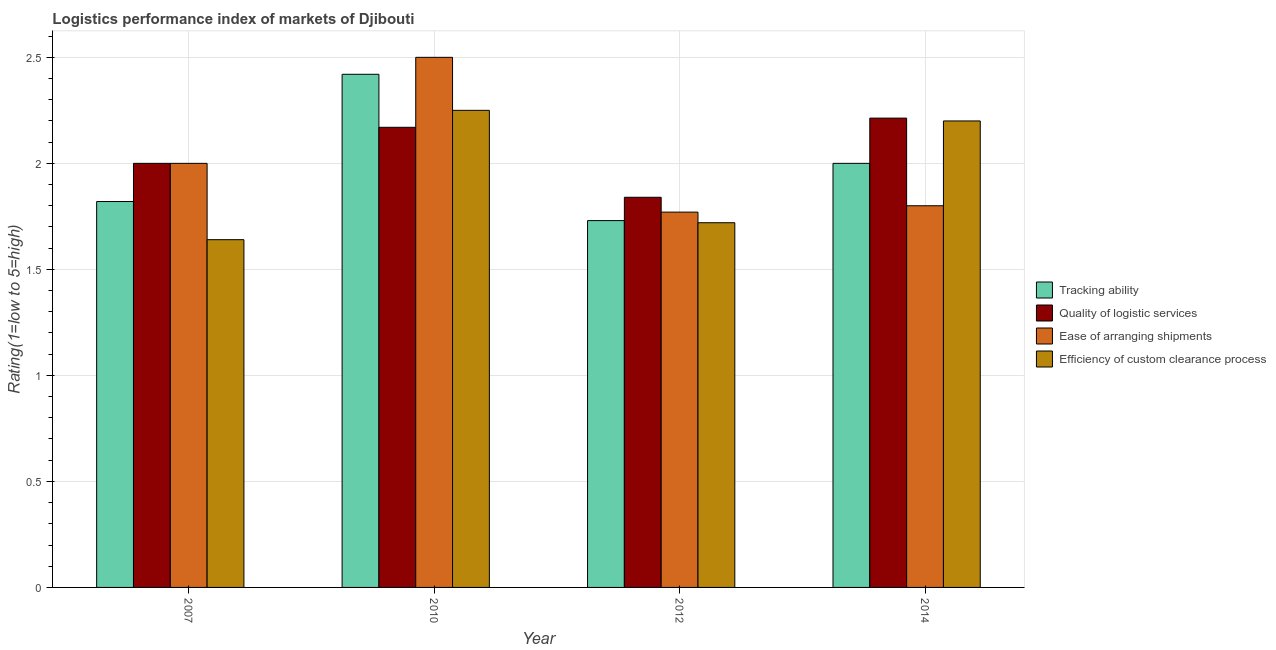How many bars are there on the 3rd tick from the left?
Provide a succinct answer. 4. Across all years, what is the maximum lpi rating of quality of logistic services?
Make the answer very short. 2.21. Across all years, what is the minimum lpi rating of ease of arranging shipments?
Make the answer very short. 1.77. In which year was the lpi rating of quality of logistic services minimum?
Offer a very short reply. 2012. What is the total lpi rating of efficiency of custom clearance process in the graph?
Provide a short and direct response. 7.81. What is the difference between the lpi rating of quality of logistic services in 2012 and that in 2014?
Ensure brevity in your answer.  -0.37. What is the difference between the lpi rating of quality of logistic services in 2010 and the lpi rating of efficiency of custom clearance process in 2012?
Ensure brevity in your answer.  0.33. What is the average lpi rating of quality of logistic services per year?
Your answer should be compact. 2.06. In how many years, is the lpi rating of efficiency of custom clearance process greater than 2?
Provide a succinct answer. 2. What is the ratio of the lpi rating of quality of logistic services in 2012 to that in 2014?
Offer a terse response. 0.83. Is the lpi rating of efficiency of custom clearance process in 2007 less than that in 2012?
Your response must be concise. Yes. Is the difference between the lpi rating of efficiency of custom clearance process in 2010 and 2012 greater than the difference between the lpi rating of ease of arranging shipments in 2010 and 2012?
Provide a succinct answer. No. What is the difference between the highest and the second highest lpi rating of quality of logistic services?
Your answer should be very brief. 0.04. What is the difference between the highest and the lowest lpi rating of ease of arranging shipments?
Your response must be concise. 0.73. Is it the case that in every year, the sum of the lpi rating of ease of arranging shipments and lpi rating of efficiency of custom clearance process is greater than the sum of lpi rating of tracking ability and lpi rating of quality of logistic services?
Provide a short and direct response. No. What does the 4th bar from the left in 2010 represents?
Keep it short and to the point. Efficiency of custom clearance process. What does the 2nd bar from the right in 2010 represents?
Your answer should be compact. Ease of arranging shipments. Is it the case that in every year, the sum of the lpi rating of tracking ability and lpi rating of quality of logistic services is greater than the lpi rating of ease of arranging shipments?
Make the answer very short. Yes. How many years are there in the graph?
Your answer should be compact. 4. Are the values on the major ticks of Y-axis written in scientific E-notation?
Provide a short and direct response. No. Does the graph contain any zero values?
Offer a very short reply. No. Does the graph contain grids?
Keep it short and to the point. Yes. Where does the legend appear in the graph?
Ensure brevity in your answer.  Center right. What is the title of the graph?
Offer a very short reply. Logistics performance index of markets of Djibouti. What is the label or title of the X-axis?
Make the answer very short. Year. What is the label or title of the Y-axis?
Provide a short and direct response. Rating(1=low to 5=high). What is the Rating(1=low to 5=high) of Tracking ability in 2007?
Ensure brevity in your answer.  1.82. What is the Rating(1=low to 5=high) of Quality of logistic services in 2007?
Keep it short and to the point. 2. What is the Rating(1=low to 5=high) in Efficiency of custom clearance process in 2007?
Your answer should be very brief. 1.64. What is the Rating(1=low to 5=high) in Tracking ability in 2010?
Provide a short and direct response. 2.42. What is the Rating(1=low to 5=high) of Quality of logistic services in 2010?
Provide a succinct answer. 2.17. What is the Rating(1=low to 5=high) of Ease of arranging shipments in 2010?
Your response must be concise. 2.5. What is the Rating(1=low to 5=high) in Efficiency of custom clearance process in 2010?
Keep it short and to the point. 2.25. What is the Rating(1=low to 5=high) of Tracking ability in 2012?
Provide a short and direct response. 1.73. What is the Rating(1=low to 5=high) of Quality of logistic services in 2012?
Your answer should be very brief. 1.84. What is the Rating(1=low to 5=high) of Ease of arranging shipments in 2012?
Ensure brevity in your answer.  1.77. What is the Rating(1=low to 5=high) of Efficiency of custom clearance process in 2012?
Make the answer very short. 1.72. What is the Rating(1=low to 5=high) in Tracking ability in 2014?
Make the answer very short. 2. What is the Rating(1=low to 5=high) of Quality of logistic services in 2014?
Provide a succinct answer. 2.21. What is the Rating(1=low to 5=high) in Ease of arranging shipments in 2014?
Give a very brief answer. 1.8. What is the Rating(1=low to 5=high) of Efficiency of custom clearance process in 2014?
Your answer should be compact. 2.2. Across all years, what is the maximum Rating(1=low to 5=high) in Tracking ability?
Keep it short and to the point. 2.42. Across all years, what is the maximum Rating(1=low to 5=high) of Quality of logistic services?
Give a very brief answer. 2.21. Across all years, what is the maximum Rating(1=low to 5=high) of Efficiency of custom clearance process?
Make the answer very short. 2.25. Across all years, what is the minimum Rating(1=low to 5=high) of Tracking ability?
Keep it short and to the point. 1.73. Across all years, what is the minimum Rating(1=low to 5=high) of Quality of logistic services?
Ensure brevity in your answer.  1.84. Across all years, what is the minimum Rating(1=low to 5=high) of Ease of arranging shipments?
Keep it short and to the point. 1.77. Across all years, what is the minimum Rating(1=low to 5=high) of Efficiency of custom clearance process?
Give a very brief answer. 1.64. What is the total Rating(1=low to 5=high) of Tracking ability in the graph?
Make the answer very short. 7.97. What is the total Rating(1=low to 5=high) in Quality of logistic services in the graph?
Your response must be concise. 8.22. What is the total Rating(1=low to 5=high) of Ease of arranging shipments in the graph?
Provide a succinct answer. 8.07. What is the total Rating(1=low to 5=high) in Efficiency of custom clearance process in the graph?
Offer a terse response. 7.81. What is the difference between the Rating(1=low to 5=high) in Tracking ability in 2007 and that in 2010?
Your answer should be compact. -0.6. What is the difference between the Rating(1=low to 5=high) of Quality of logistic services in 2007 and that in 2010?
Keep it short and to the point. -0.17. What is the difference between the Rating(1=low to 5=high) of Ease of arranging shipments in 2007 and that in 2010?
Your answer should be compact. -0.5. What is the difference between the Rating(1=low to 5=high) in Efficiency of custom clearance process in 2007 and that in 2010?
Offer a terse response. -0.61. What is the difference between the Rating(1=low to 5=high) of Tracking ability in 2007 and that in 2012?
Your answer should be very brief. 0.09. What is the difference between the Rating(1=low to 5=high) of Quality of logistic services in 2007 and that in 2012?
Your response must be concise. 0.16. What is the difference between the Rating(1=low to 5=high) of Ease of arranging shipments in 2007 and that in 2012?
Ensure brevity in your answer.  0.23. What is the difference between the Rating(1=low to 5=high) in Efficiency of custom clearance process in 2007 and that in 2012?
Make the answer very short. -0.08. What is the difference between the Rating(1=low to 5=high) in Tracking ability in 2007 and that in 2014?
Keep it short and to the point. -0.18. What is the difference between the Rating(1=low to 5=high) in Quality of logistic services in 2007 and that in 2014?
Offer a terse response. -0.21. What is the difference between the Rating(1=low to 5=high) of Efficiency of custom clearance process in 2007 and that in 2014?
Ensure brevity in your answer.  -0.56. What is the difference between the Rating(1=low to 5=high) in Tracking ability in 2010 and that in 2012?
Your response must be concise. 0.69. What is the difference between the Rating(1=low to 5=high) in Quality of logistic services in 2010 and that in 2012?
Provide a short and direct response. 0.33. What is the difference between the Rating(1=low to 5=high) of Ease of arranging shipments in 2010 and that in 2012?
Make the answer very short. 0.73. What is the difference between the Rating(1=low to 5=high) of Efficiency of custom clearance process in 2010 and that in 2012?
Keep it short and to the point. 0.53. What is the difference between the Rating(1=low to 5=high) in Tracking ability in 2010 and that in 2014?
Make the answer very short. 0.42. What is the difference between the Rating(1=low to 5=high) of Quality of logistic services in 2010 and that in 2014?
Offer a very short reply. -0.04. What is the difference between the Rating(1=low to 5=high) in Tracking ability in 2012 and that in 2014?
Give a very brief answer. -0.27. What is the difference between the Rating(1=low to 5=high) in Quality of logistic services in 2012 and that in 2014?
Keep it short and to the point. -0.37. What is the difference between the Rating(1=low to 5=high) of Ease of arranging shipments in 2012 and that in 2014?
Provide a succinct answer. -0.03. What is the difference between the Rating(1=low to 5=high) in Efficiency of custom clearance process in 2012 and that in 2014?
Offer a very short reply. -0.48. What is the difference between the Rating(1=low to 5=high) in Tracking ability in 2007 and the Rating(1=low to 5=high) in Quality of logistic services in 2010?
Ensure brevity in your answer.  -0.35. What is the difference between the Rating(1=low to 5=high) of Tracking ability in 2007 and the Rating(1=low to 5=high) of Ease of arranging shipments in 2010?
Provide a succinct answer. -0.68. What is the difference between the Rating(1=low to 5=high) in Tracking ability in 2007 and the Rating(1=low to 5=high) in Efficiency of custom clearance process in 2010?
Provide a short and direct response. -0.43. What is the difference between the Rating(1=low to 5=high) in Quality of logistic services in 2007 and the Rating(1=low to 5=high) in Efficiency of custom clearance process in 2010?
Your answer should be very brief. -0.25. What is the difference between the Rating(1=low to 5=high) in Ease of arranging shipments in 2007 and the Rating(1=low to 5=high) in Efficiency of custom clearance process in 2010?
Offer a terse response. -0.25. What is the difference between the Rating(1=low to 5=high) of Tracking ability in 2007 and the Rating(1=low to 5=high) of Quality of logistic services in 2012?
Keep it short and to the point. -0.02. What is the difference between the Rating(1=low to 5=high) of Tracking ability in 2007 and the Rating(1=low to 5=high) of Ease of arranging shipments in 2012?
Your response must be concise. 0.05. What is the difference between the Rating(1=low to 5=high) of Tracking ability in 2007 and the Rating(1=low to 5=high) of Efficiency of custom clearance process in 2012?
Provide a short and direct response. 0.1. What is the difference between the Rating(1=low to 5=high) in Quality of logistic services in 2007 and the Rating(1=low to 5=high) in Ease of arranging shipments in 2012?
Give a very brief answer. 0.23. What is the difference between the Rating(1=low to 5=high) of Quality of logistic services in 2007 and the Rating(1=low to 5=high) of Efficiency of custom clearance process in 2012?
Give a very brief answer. 0.28. What is the difference between the Rating(1=low to 5=high) of Ease of arranging shipments in 2007 and the Rating(1=low to 5=high) of Efficiency of custom clearance process in 2012?
Provide a succinct answer. 0.28. What is the difference between the Rating(1=low to 5=high) in Tracking ability in 2007 and the Rating(1=low to 5=high) in Quality of logistic services in 2014?
Your response must be concise. -0.39. What is the difference between the Rating(1=low to 5=high) in Tracking ability in 2007 and the Rating(1=low to 5=high) in Efficiency of custom clearance process in 2014?
Your response must be concise. -0.38. What is the difference between the Rating(1=low to 5=high) of Quality of logistic services in 2007 and the Rating(1=low to 5=high) of Ease of arranging shipments in 2014?
Your response must be concise. 0.2. What is the difference between the Rating(1=low to 5=high) of Tracking ability in 2010 and the Rating(1=low to 5=high) of Quality of logistic services in 2012?
Your answer should be compact. 0.58. What is the difference between the Rating(1=low to 5=high) of Tracking ability in 2010 and the Rating(1=low to 5=high) of Ease of arranging shipments in 2012?
Provide a succinct answer. 0.65. What is the difference between the Rating(1=low to 5=high) of Tracking ability in 2010 and the Rating(1=low to 5=high) of Efficiency of custom clearance process in 2012?
Offer a terse response. 0.7. What is the difference between the Rating(1=low to 5=high) in Quality of logistic services in 2010 and the Rating(1=low to 5=high) in Ease of arranging shipments in 2012?
Give a very brief answer. 0.4. What is the difference between the Rating(1=low to 5=high) of Quality of logistic services in 2010 and the Rating(1=low to 5=high) of Efficiency of custom clearance process in 2012?
Make the answer very short. 0.45. What is the difference between the Rating(1=low to 5=high) of Ease of arranging shipments in 2010 and the Rating(1=low to 5=high) of Efficiency of custom clearance process in 2012?
Ensure brevity in your answer.  0.78. What is the difference between the Rating(1=low to 5=high) of Tracking ability in 2010 and the Rating(1=low to 5=high) of Quality of logistic services in 2014?
Give a very brief answer. 0.21. What is the difference between the Rating(1=low to 5=high) in Tracking ability in 2010 and the Rating(1=low to 5=high) in Ease of arranging shipments in 2014?
Offer a terse response. 0.62. What is the difference between the Rating(1=low to 5=high) in Tracking ability in 2010 and the Rating(1=low to 5=high) in Efficiency of custom clearance process in 2014?
Provide a succinct answer. 0.22. What is the difference between the Rating(1=low to 5=high) in Quality of logistic services in 2010 and the Rating(1=low to 5=high) in Ease of arranging shipments in 2014?
Ensure brevity in your answer.  0.37. What is the difference between the Rating(1=low to 5=high) of Quality of logistic services in 2010 and the Rating(1=low to 5=high) of Efficiency of custom clearance process in 2014?
Give a very brief answer. -0.03. What is the difference between the Rating(1=low to 5=high) in Ease of arranging shipments in 2010 and the Rating(1=low to 5=high) in Efficiency of custom clearance process in 2014?
Provide a succinct answer. 0.3. What is the difference between the Rating(1=low to 5=high) of Tracking ability in 2012 and the Rating(1=low to 5=high) of Quality of logistic services in 2014?
Offer a very short reply. -0.48. What is the difference between the Rating(1=low to 5=high) of Tracking ability in 2012 and the Rating(1=low to 5=high) of Ease of arranging shipments in 2014?
Your answer should be compact. -0.07. What is the difference between the Rating(1=low to 5=high) of Tracking ability in 2012 and the Rating(1=low to 5=high) of Efficiency of custom clearance process in 2014?
Give a very brief answer. -0.47. What is the difference between the Rating(1=low to 5=high) in Quality of logistic services in 2012 and the Rating(1=low to 5=high) in Ease of arranging shipments in 2014?
Ensure brevity in your answer.  0.04. What is the difference between the Rating(1=low to 5=high) of Quality of logistic services in 2012 and the Rating(1=low to 5=high) of Efficiency of custom clearance process in 2014?
Your response must be concise. -0.36. What is the difference between the Rating(1=low to 5=high) of Ease of arranging shipments in 2012 and the Rating(1=low to 5=high) of Efficiency of custom clearance process in 2014?
Offer a terse response. -0.43. What is the average Rating(1=low to 5=high) of Tracking ability per year?
Ensure brevity in your answer.  1.99. What is the average Rating(1=low to 5=high) in Quality of logistic services per year?
Offer a very short reply. 2.06. What is the average Rating(1=low to 5=high) in Ease of arranging shipments per year?
Provide a short and direct response. 2.02. What is the average Rating(1=low to 5=high) in Efficiency of custom clearance process per year?
Make the answer very short. 1.95. In the year 2007, what is the difference between the Rating(1=low to 5=high) in Tracking ability and Rating(1=low to 5=high) in Quality of logistic services?
Your answer should be very brief. -0.18. In the year 2007, what is the difference between the Rating(1=low to 5=high) in Tracking ability and Rating(1=low to 5=high) in Ease of arranging shipments?
Give a very brief answer. -0.18. In the year 2007, what is the difference between the Rating(1=low to 5=high) of Tracking ability and Rating(1=low to 5=high) of Efficiency of custom clearance process?
Provide a short and direct response. 0.18. In the year 2007, what is the difference between the Rating(1=low to 5=high) in Quality of logistic services and Rating(1=low to 5=high) in Ease of arranging shipments?
Offer a very short reply. 0. In the year 2007, what is the difference between the Rating(1=low to 5=high) in Quality of logistic services and Rating(1=low to 5=high) in Efficiency of custom clearance process?
Provide a short and direct response. 0.36. In the year 2007, what is the difference between the Rating(1=low to 5=high) of Ease of arranging shipments and Rating(1=low to 5=high) of Efficiency of custom clearance process?
Offer a terse response. 0.36. In the year 2010, what is the difference between the Rating(1=low to 5=high) in Tracking ability and Rating(1=low to 5=high) in Quality of logistic services?
Ensure brevity in your answer.  0.25. In the year 2010, what is the difference between the Rating(1=low to 5=high) in Tracking ability and Rating(1=low to 5=high) in Ease of arranging shipments?
Provide a succinct answer. -0.08. In the year 2010, what is the difference between the Rating(1=low to 5=high) in Tracking ability and Rating(1=low to 5=high) in Efficiency of custom clearance process?
Provide a short and direct response. 0.17. In the year 2010, what is the difference between the Rating(1=low to 5=high) of Quality of logistic services and Rating(1=low to 5=high) of Ease of arranging shipments?
Offer a terse response. -0.33. In the year 2010, what is the difference between the Rating(1=low to 5=high) in Quality of logistic services and Rating(1=low to 5=high) in Efficiency of custom clearance process?
Make the answer very short. -0.08. In the year 2010, what is the difference between the Rating(1=low to 5=high) in Ease of arranging shipments and Rating(1=low to 5=high) in Efficiency of custom clearance process?
Your answer should be very brief. 0.25. In the year 2012, what is the difference between the Rating(1=low to 5=high) of Tracking ability and Rating(1=low to 5=high) of Quality of logistic services?
Your answer should be very brief. -0.11. In the year 2012, what is the difference between the Rating(1=low to 5=high) of Tracking ability and Rating(1=low to 5=high) of Ease of arranging shipments?
Make the answer very short. -0.04. In the year 2012, what is the difference between the Rating(1=low to 5=high) in Quality of logistic services and Rating(1=low to 5=high) in Ease of arranging shipments?
Offer a very short reply. 0.07. In the year 2012, what is the difference between the Rating(1=low to 5=high) in Quality of logistic services and Rating(1=low to 5=high) in Efficiency of custom clearance process?
Give a very brief answer. 0.12. In the year 2012, what is the difference between the Rating(1=low to 5=high) in Ease of arranging shipments and Rating(1=low to 5=high) in Efficiency of custom clearance process?
Offer a very short reply. 0.05. In the year 2014, what is the difference between the Rating(1=low to 5=high) of Tracking ability and Rating(1=low to 5=high) of Quality of logistic services?
Make the answer very short. -0.21. In the year 2014, what is the difference between the Rating(1=low to 5=high) of Quality of logistic services and Rating(1=low to 5=high) of Ease of arranging shipments?
Your response must be concise. 0.41. In the year 2014, what is the difference between the Rating(1=low to 5=high) of Quality of logistic services and Rating(1=low to 5=high) of Efficiency of custom clearance process?
Keep it short and to the point. 0.01. What is the ratio of the Rating(1=low to 5=high) of Tracking ability in 2007 to that in 2010?
Your response must be concise. 0.75. What is the ratio of the Rating(1=low to 5=high) in Quality of logistic services in 2007 to that in 2010?
Make the answer very short. 0.92. What is the ratio of the Rating(1=low to 5=high) of Ease of arranging shipments in 2007 to that in 2010?
Give a very brief answer. 0.8. What is the ratio of the Rating(1=low to 5=high) in Efficiency of custom clearance process in 2007 to that in 2010?
Make the answer very short. 0.73. What is the ratio of the Rating(1=low to 5=high) in Tracking ability in 2007 to that in 2012?
Make the answer very short. 1.05. What is the ratio of the Rating(1=low to 5=high) in Quality of logistic services in 2007 to that in 2012?
Provide a succinct answer. 1.09. What is the ratio of the Rating(1=low to 5=high) in Ease of arranging shipments in 2007 to that in 2012?
Keep it short and to the point. 1.13. What is the ratio of the Rating(1=low to 5=high) of Efficiency of custom clearance process in 2007 to that in 2012?
Keep it short and to the point. 0.95. What is the ratio of the Rating(1=low to 5=high) in Tracking ability in 2007 to that in 2014?
Make the answer very short. 0.91. What is the ratio of the Rating(1=low to 5=high) in Quality of logistic services in 2007 to that in 2014?
Give a very brief answer. 0.9. What is the ratio of the Rating(1=low to 5=high) in Efficiency of custom clearance process in 2007 to that in 2014?
Give a very brief answer. 0.75. What is the ratio of the Rating(1=low to 5=high) in Tracking ability in 2010 to that in 2012?
Your response must be concise. 1.4. What is the ratio of the Rating(1=low to 5=high) of Quality of logistic services in 2010 to that in 2012?
Offer a very short reply. 1.18. What is the ratio of the Rating(1=low to 5=high) of Ease of arranging shipments in 2010 to that in 2012?
Your answer should be very brief. 1.41. What is the ratio of the Rating(1=low to 5=high) in Efficiency of custom clearance process in 2010 to that in 2012?
Your answer should be very brief. 1.31. What is the ratio of the Rating(1=low to 5=high) in Tracking ability in 2010 to that in 2014?
Give a very brief answer. 1.21. What is the ratio of the Rating(1=low to 5=high) of Quality of logistic services in 2010 to that in 2014?
Your answer should be very brief. 0.98. What is the ratio of the Rating(1=low to 5=high) of Ease of arranging shipments in 2010 to that in 2014?
Ensure brevity in your answer.  1.39. What is the ratio of the Rating(1=low to 5=high) in Efficiency of custom clearance process in 2010 to that in 2014?
Provide a succinct answer. 1.02. What is the ratio of the Rating(1=low to 5=high) in Tracking ability in 2012 to that in 2014?
Keep it short and to the point. 0.86. What is the ratio of the Rating(1=low to 5=high) in Quality of logistic services in 2012 to that in 2014?
Keep it short and to the point. 0.83. What is the ratio of the Rating(1=low to 5=high) in Ease of arranging shipments in 2012 to that in 2014?
Ensure brevity in your answer.  0.98. What is the ratio of the Rating(1=low to 5=high) of Efficiency of custom clearance process in 2012 to that in 2014?
Your answer should be compact. 0.78. What is the difference between the highest and the second highest Rating(1=low to 5=high) of Tracking ability?
Make the answer very short. 0.42. What is the difference between the highest and the second highest Rating(1=low to 5=high) of Quality of logistic services?
Provide a short and direct response. 0.04. What is the difference between the highest and the lowest Rating(1=low to 5=high) in Tracking ability?
Offer a terse response. 0.69. What is the difference between the highest and the lowest Rating(1=low to 5=high) in Quality of logistic services?
Provide a succinct answer. 0.37. What is the difference between the highest and the lowest Rating(1=low to 5=high) of Ease of arranging shipments?
Your answer should be very brief. 0.73. What is the difference between the highest and the lowest Rating(1=low to 5=high) of Efficiency of custom clearance process?
Keep it short and to the point. 0.61. 